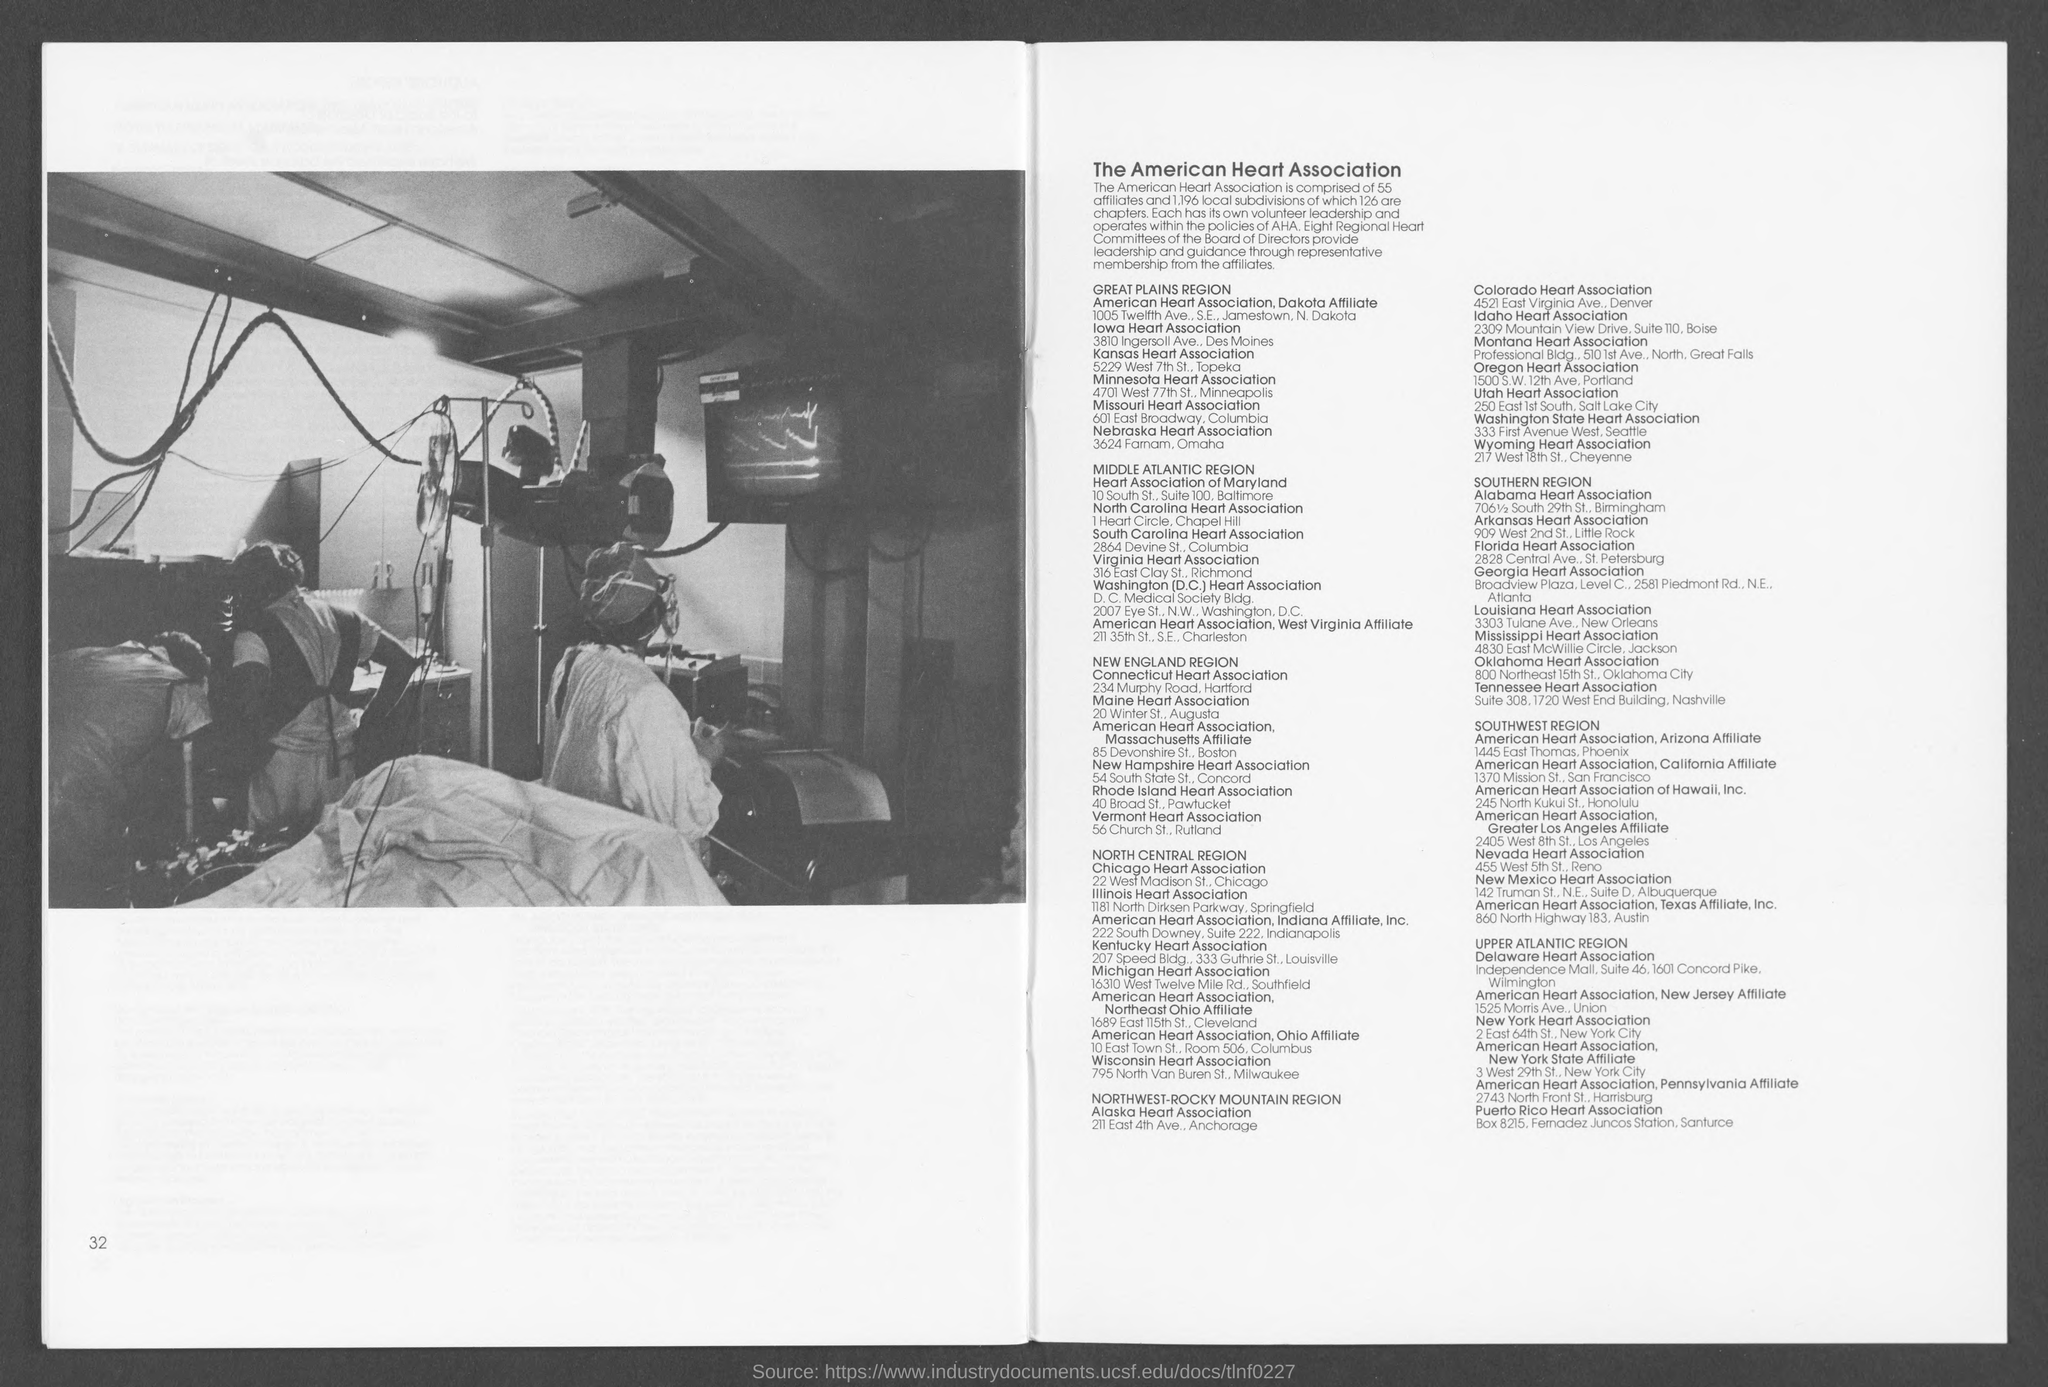How many affliates does The american Heart Association have?
Provide a short and direct response. 55. What is the number of chapters mentioned?
Offer a terse response. 126. How many Regional Heart Committees of the Board of Directors provide leadership and guidance?
Provide a short and direct response. Eight. What is the address of Colorado Heart Association?
Your response must be concise. 4521 east virginia ave., denver. What is the address of Nebraska Heart Association?
Your response must be concise. 3624 farnam, omaha. What is the address of Utah Heart Association?
Keep it short and to the point. 250 east 1st south, salt lake city. What is the address of Oregon Heart Association?
Make the answer very short. 1500 S.W. 12th Ave, Portland. What is the address of Washington State Heart Association?
Give a very brief answer. 333 first avenue west, seattle. What is the address of Mississippi Heart Association?
Your response must be concise. 4830 east mcwillie circle, jackson. 